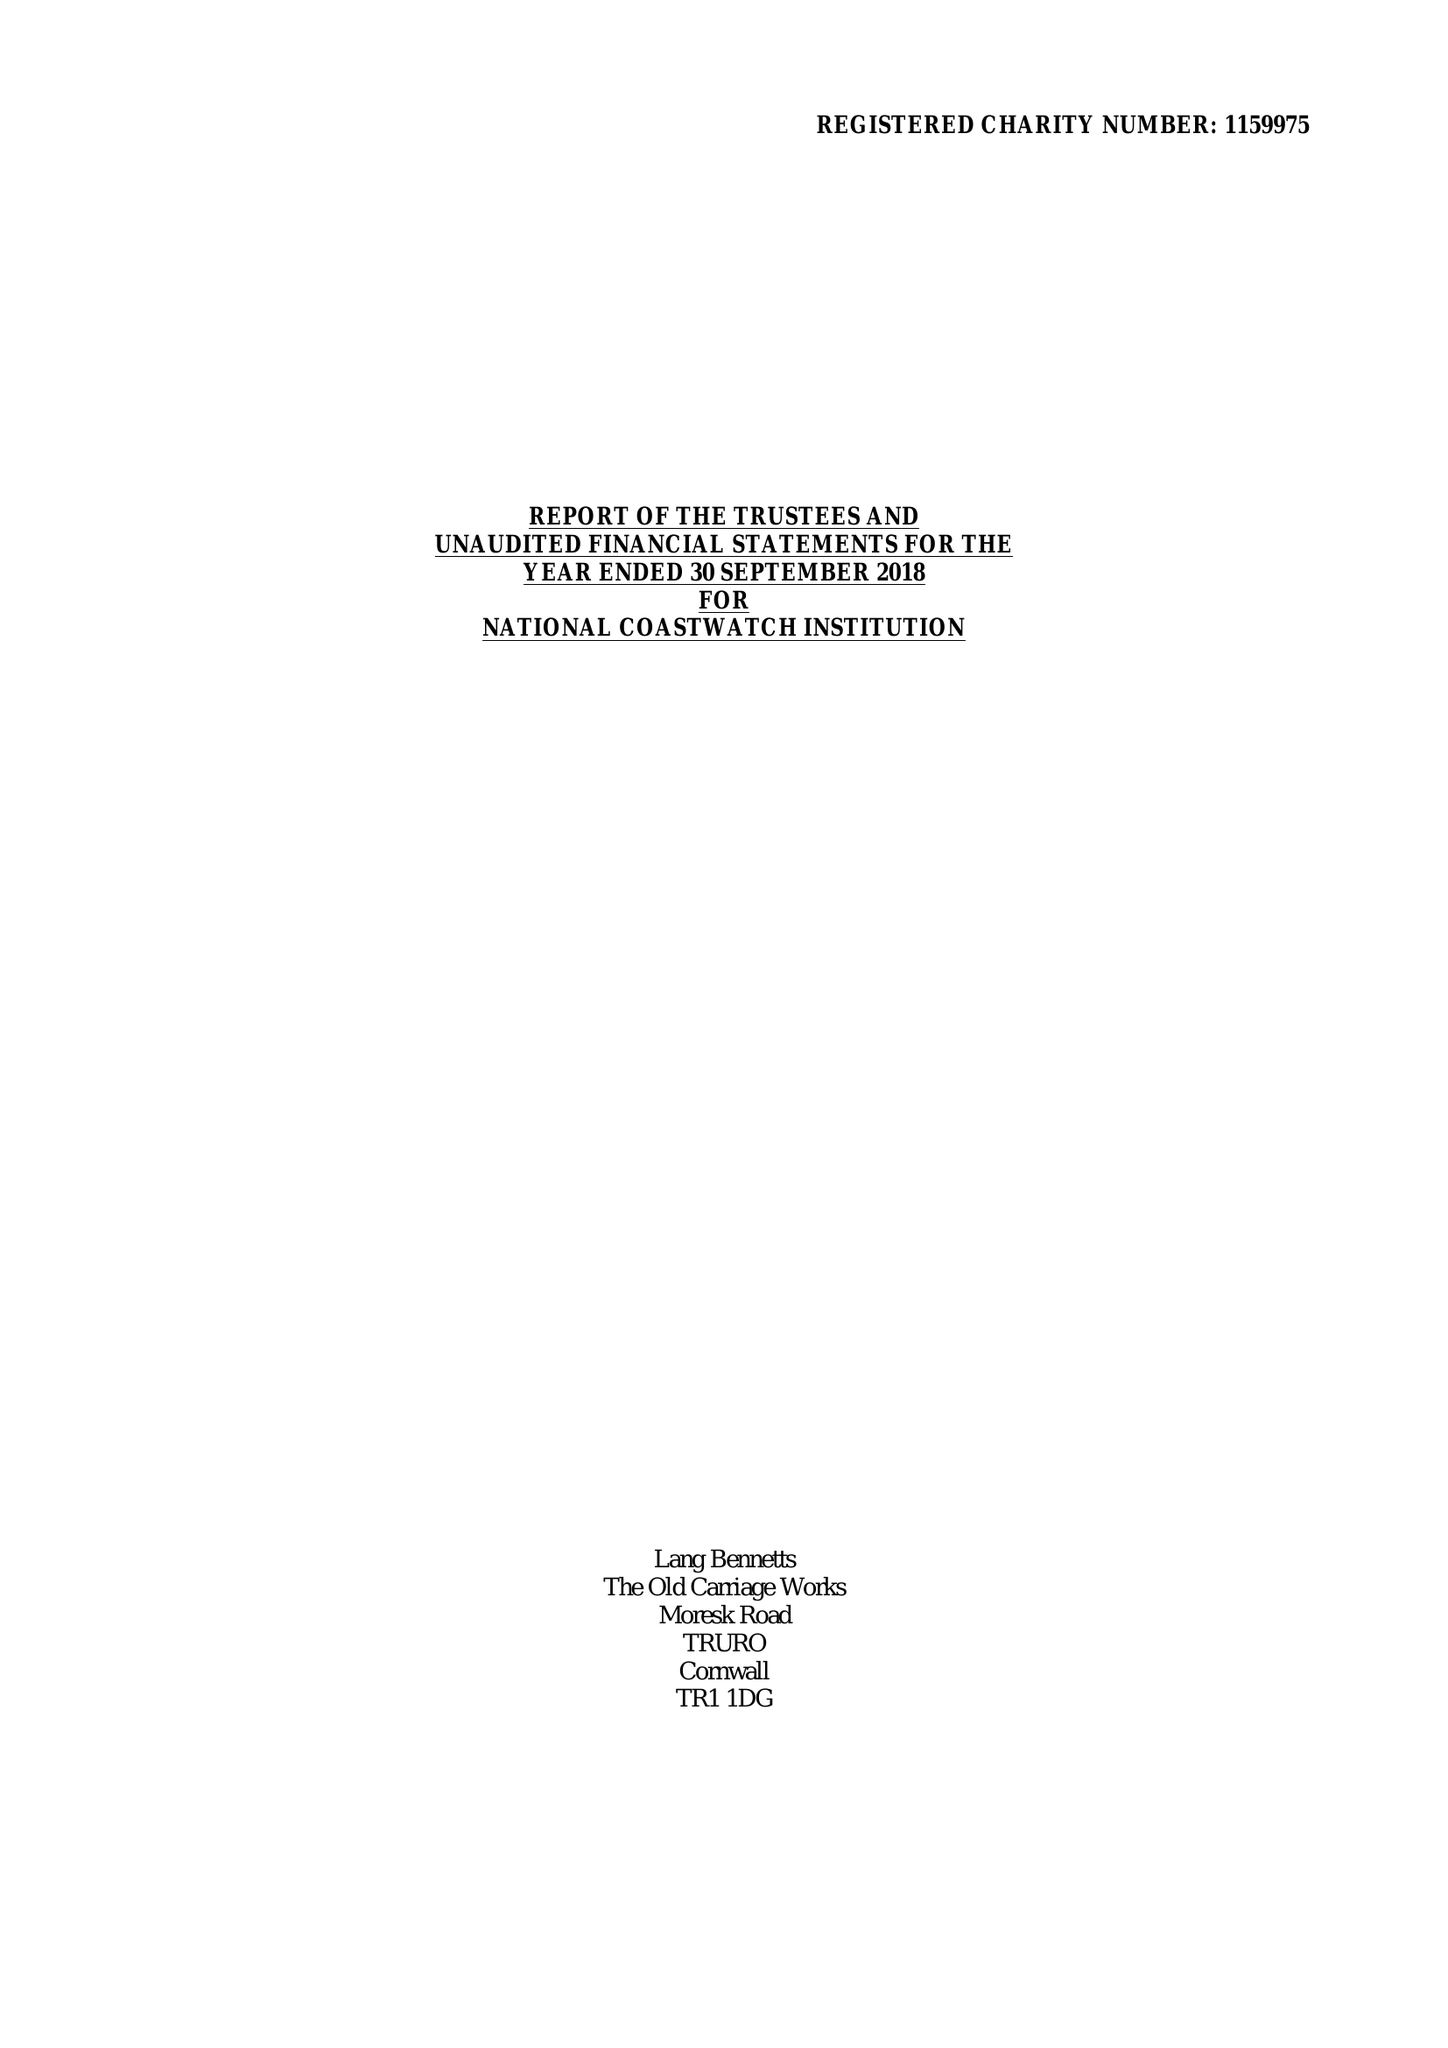What is the value for the report_date?
Answer the question using a single word or phrase. 2018-09-30 